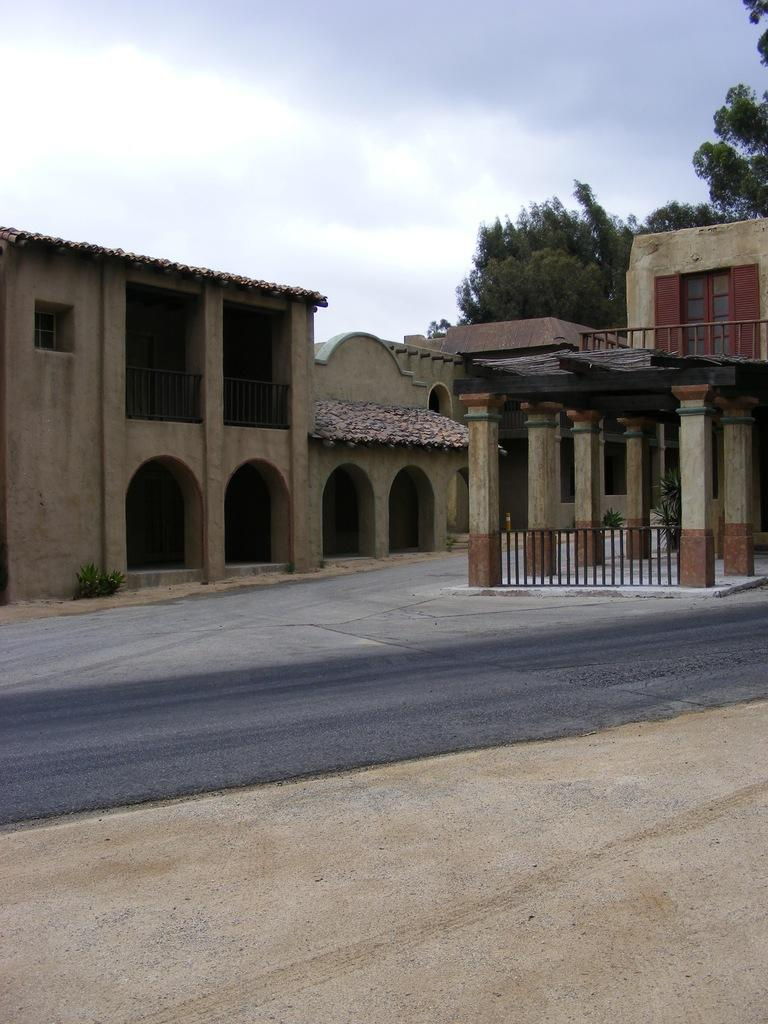What type of structures can be seen in the image? There are houses in the image. What architectural elements are present in the image? There are pillars in the image. What type of vegetation is visible in the image? There are plants and trees in the image. What is the pathway for vehicles or pedestrians in the image? There is a road in the image. What can be seen in the background of the image? The sky is visible in the background of the image. Where is the crowd gathered in the image? There is no crowd present in the image. What type of wrist accessory is visible on the trees in the image? There are no wrist accessories present in the image; it features houses, pillars, plants, trees, a road, and the sky. 